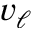Convert formula to latex. <formula><loc_0><loc_0><loc_500><loc_500>v _ { \ell }</formula> 